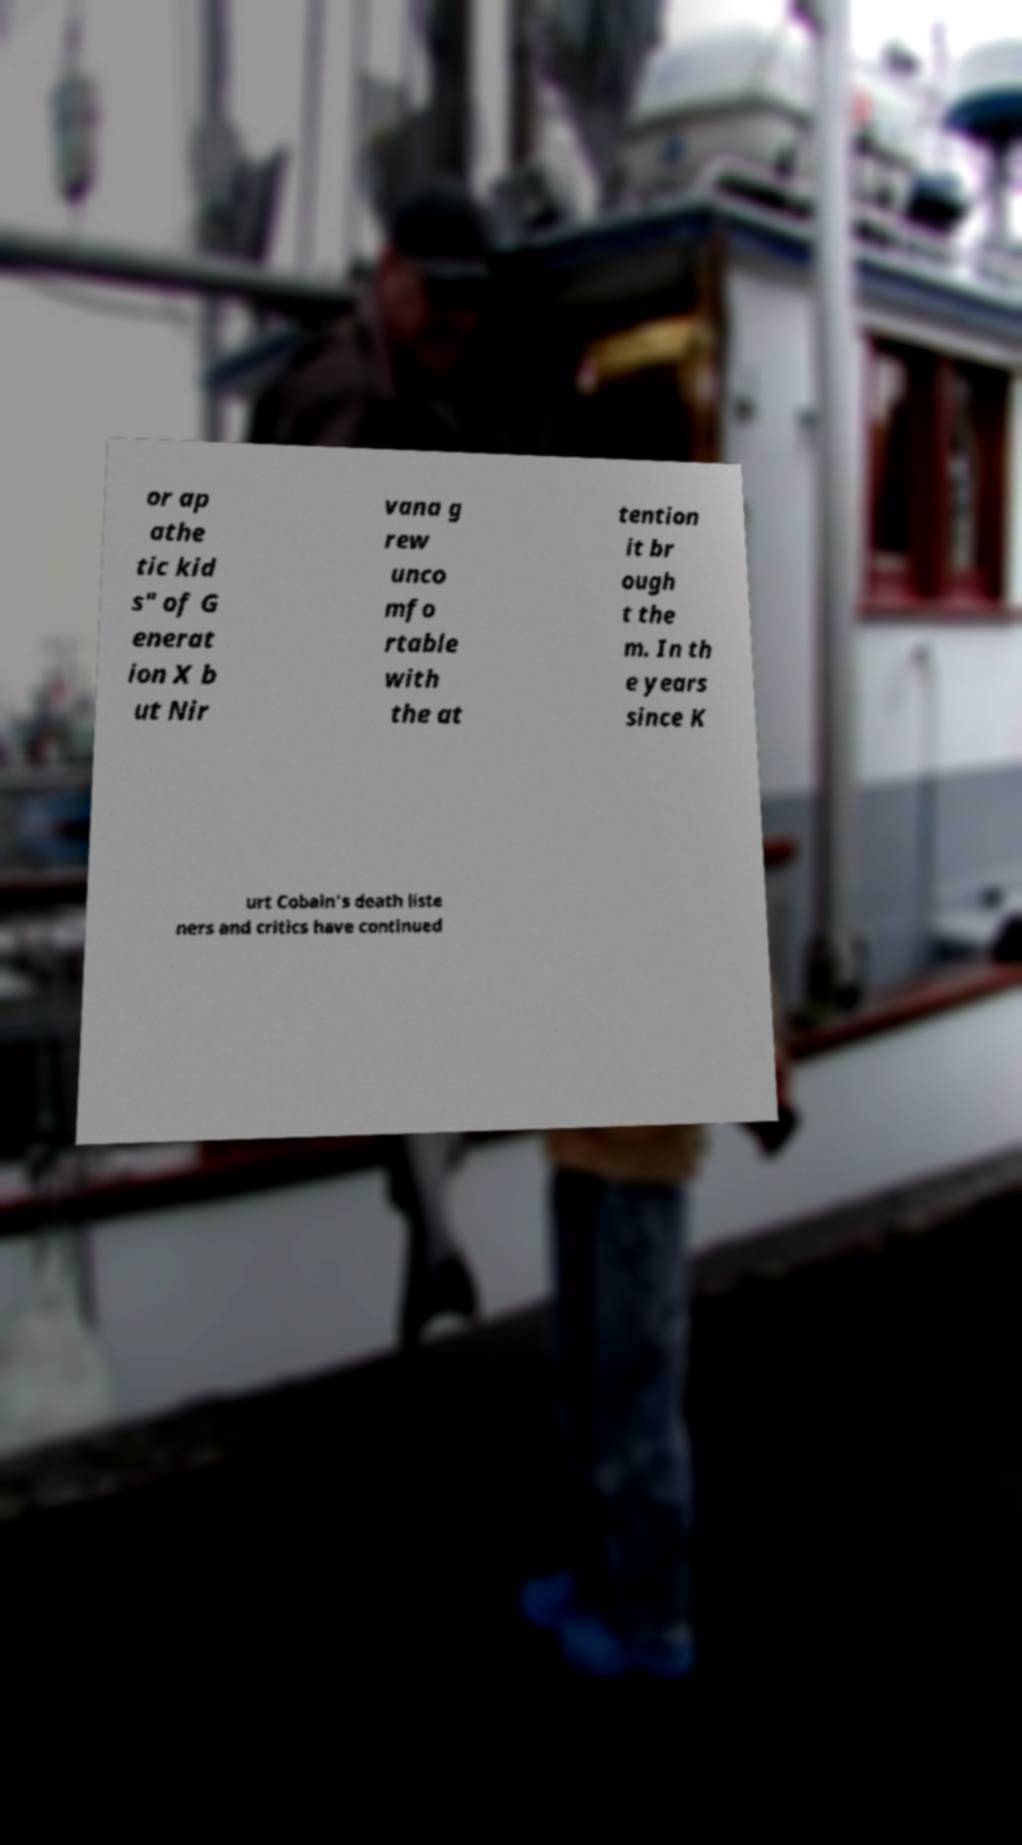Can you accurately transcribe the text from the provided image for me? or ap athe tic kid s" of G enerat ion X b ut Nir vana g rew unco mfo rtable with the at tention it br ough t the m. In th e years since K urt Cobain's death liste ners and critics have continued 